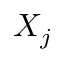Convert formula to latex. <formula><loc_0><loc_0><loc_500><loc_500>X _ { j }</formula> 